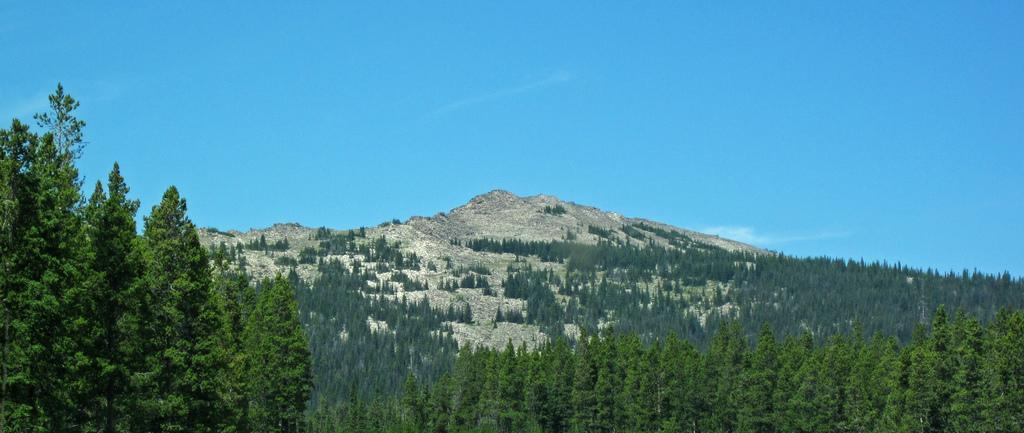What type of vegetation can be seen in the image? There are groups of trees in the image. What natural feature is visible in the background of the image? There are mountains in the background of the image. What is visible at the top of the image? The sky is visible at the top of the image. What type of flesh can be seen on the trees in the image? There is no flesh present on the trees in the image; they are made of wood and leaves. Can you describe the sun's position in the image? There is no sun present in the image; only the sky is visible at the top. 